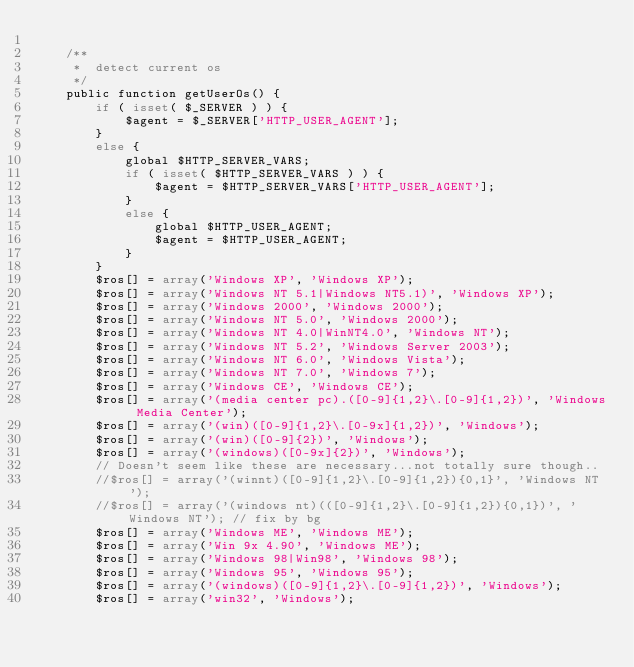<code> <loc_0><loc_0><loc_500><loc_500><_PHP_>
	/**
	 *	detect current os
	 */
	public function getUserOs() {
		if ( isset( $_SERVER ) ) {
			$agent = $_SERVER['HTTP_USER_AGENT'];
		}
		else {
			global $HTTP_SERVER_VARS;
			if ( isset( $HTTP_SERVER_VARS ) ) {
				$agent = $HTTP_SERVER_VARS['HTTP_USER_AGENT'];
			}
			else {
				global $HTTP_USER_AGENT;
				$agent = $HTTP_USER_AGENT;
			}
		}
		$ros[] = array('Windows XP', 'Windows XP');
		$ros[] = array('Windows NT 5.1|Windows NT5.1)', 'Windows XP');
		$ros[] = array('Windows 2000', 'Windows 2000');
		$ros[] = array('Windows NT 5.0', 'Windows 2000');
		$ros[] = array('Windows NT 4.0|WinNT4.0', 'Windows NT');
		$ros[] = array('Windows NT 5.2', 'Windows Server 2003');
		$ros[] = array('Windows NT 6.0', 'Windows Vista');
		$ros[] = array('Windows NT 7.0', 'Windows 7');
		$ros[] = array('Windows CE', 'Windows CE');
		$ros[] = array('(media center pc).([0-9]{1,2}\.[0-9]{1,2})', 'Windows Media Center');
		$ros[] = array('(win)([0-9]{1,2}\.[0-9x]{1,2})', 'Windows');
		$ros[] = array('(win)([0-9]{2})', 'Windows');
		$ros[] = array('(windows)([0-9x]{2})', 'Windows');
		// Doesn't seem like these are necessary...not totally sure though..
		//$ros[] = array('(winnt)([0-9]{1,2}\.[0-9]{1,2}){0,1}', 'Windows NT');
		//$ros[] = array('(windows nt)(([0-9]{1,2}\.[0-9]{1,2}){0,1})', 'Windows NT'); // fix by bg
		$ros[] = array('Windows ME', 'Windows ME');
		$ros[] = array('Win 9x 4.90', 'Windows ME');
		$ros[] = array('Windows 98|Win98', 'Windows 98');
		$ros[] = array('Windows 95', 'Windows 95');
		$ros[] = array('(windows)([0-9]{1,2}\.[0-9]{1,2})', 'Windows');
		$ros[] = array('win32', 'Windows');</code> 